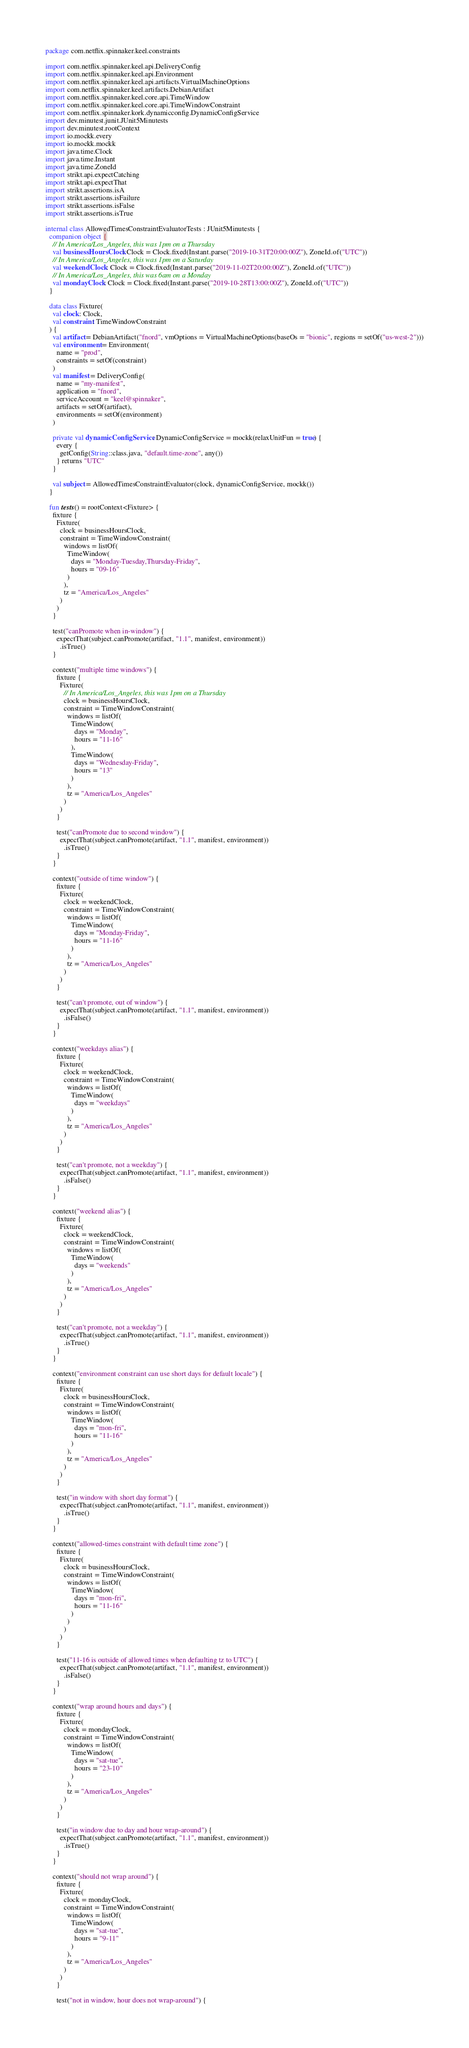<code> <loc_0><loc_0><loc_500><loc_500><_Kotlin_>package com.netflix.spinnaker.keel.constraints

import com.netflix.spinnaker.keel.api.DeliveryConfig
import com.netflix.spinnaker.keel.api.Environment
import com.netflix.spinnaker.keel.api.artifacts.VirtualMachineOptions
import com.netflix.spinnaker.keel.artifacts.DebianArtifact
import com.netflix.spinnaker.keel.core.api.TimeWindow
import com.netflix.spinnaker.keel.core.api.TimeWindowConstraint
import com.netflix.spinnaker.kork.dynamicconfig.DynamicConfigService
import dev.minutest.junit.JUnit5Minutests
import dev.minutest.rootContext
import io.mockk.every
import io.mockk.mockk
import java.time.Clock
import java.time.Instant
import java.time.ZoneId
import strikt.api.expectCatching
import strikt.api.expectThat
import strikt.assertions.isA
import strikt.assertions.isFailure
import strikt.assertions.isFalse
import strikt.assertions.isTrue

internal class AllowedTimesConstraintEvaluatorTests : JUnit5Minutests {
  companion object {
    // In America/Los_Angeles, this was 1pm on a Thursday
    val businessHoursClock: Clock = Clock.fixed(Instant.parse("2019-10-31T20:00:00Z"), ZoneId.of("UTC"))
    // In America/Los_Angeles, this was 1pm on a Saturday
    val weekendClock: Clock = Clock.fixed(Instant.parse("2019-11-02T20:00:00Z"), ZoneId.of("UTC"))
    // In America/Los_Angeles, this was 6am on a Monday
    val mondayClock: Clock = Clock.fixed(Instant.parse("2019-10-28T13:00:00Z"), ZoneId.of("UTC"))
  }

  data class Fixture(
    val clock: Clock,
    val constraint: TimeWindowConstraint
  ) {
    val artifact = DebianArtifact("fnord", vmOptions = VirtualMachineOptions(baseOs = "bionic", regions = setOf("us-west-2")))
    val environment = Environment(
      name = "prod",
      constraints = setOf(constraint)
    )
    val manifest = DeliveryConfig(
      name = "my-manifest",
      application = "fnord",
      serviceAccount = "keel@spinnaker",
      artifacts = setOf(artifact),
      environments = setOf(environment)
    )

    private val dynamicConfigService: DynamicConfigService = mockk(relaxUnitFun = true) {
      every {
        getConfig(String::class.java, "default.time-zone", any())
      } returns "UTC"
    }

    val subject = AllowedTimesConstraintEvaluator(clock, dynamicConfigService, mockk())
  }

  fun tests() = rootContext<Fixture> {
    fixture {
      Fixture(
        clock = businessHoursClock,
        constraint = TimeWindowConstraint(
          windows = listOf(
            TimeWindow(
              days = "Monday-Tuesday,Thursday-Friday",
              hours = "09-16"
            )
          ),
          tz = "America/Los_Angeles"
        )
      )
    }

    test("canPromote when in-window") {
      expectThat(subject.canPromote(artifact, "1.1", manifest, environment))
        .isTrue()
    }

    context("multiple time windows") {
      fixture {
        Fixture(
          // In America/Los_Angeles, this was 1pm on a Thursday
          clock = businessHoursClock,
          constraint = TimeWindowConstraint(
            windows = listOf(
              TimeWindow(
                days = "Monday",
                hours = "11-16"
              ),
              TimeWindow(
                days = "Wednesday-Friday",
                hours = "13"
              )
            ),
            tz = "America/Los_Angeles"
          )
        )
      }

      test("canPromote due to second window") {
        expectThat(subject.canPromote(artifact, "1.1", manifest, environment))
          .isTrue()
      }
    }

    context("outside of time window") {
      fixture {
        Fixture(
          clock = weekendClock,
          constraint = TimeWindowConstraint(
            windows = listOf(
              TimeWindow(
                days = "Monday-Friday",
                hours = "11-16"
              )
            ),
            tz = "America/Los_Angeles"
          )
        )
      }

      test("can't promote, out of window") {
        expectThat(subject.canPromote(artifact, "1.1", manifest, environment))
          .isFalse()
      }
    }

    context("weekdays alias") {
      fixture {
        Fixture(
          clock = weekendClock,
          constraint = TimeWindowConstraint(
            windows = listOf(
              TimeWindow(
                days = "weekdays"
              )
            ),
            tz = "America/Los_Angeles"
          )
        )
      }

      test("can't promote, not a weekday") {
        expectThat(subject.canPromote(artifact, "1.1", manifest, environment))
          .isFalse()
      }
    }

    context("weekend alias") {
      fixture {
        Fixture(
          clock = weekendClock,
          constraint = TimeWindowConstraint(
            windows = listOf(
              TimeWindow(
                days = "weekends"
              )
            ),
            tz = "America/Los_Angeles"
          )
        )
      }

      test("can't promote, not a weekday") {
        expectThat(subject.canPromote(artifact, "1.1", manifest, environment))
          .isTrue()
      }
    }

    context("environment constraint can use short days for default locale") {
      fixture {
        Fixture(
          clock = businessHoursClock,
          constraint = TimeWindowConstraint(
            windows = listOf(
              TimeWindow(
                days = "mon-fri",
                hours = "11-16"
              )
            ),
            tz = "America/Los_Angeles"
          )
        )
      }

      test("in window with short day format") {
        expectThat(subject.canPromote(artifact, "1.1", manifest, environment))
          .isTrue()
      }
    }

    context("allowed-times constraint with default time zone") {
      fixture {
        Fixture(
          clock = businessHoursClock,
          constraint = TimeWindowConstraint(
            windows = listOf(
              TimeWindow(
                days = "mon-fri",
                hours = "11-16"
              )
            )
          )
        )
      }

      test("11-16 is outside of allowed times when defaulting tz to UTC") {
        expectThat(subject.canPromote(artifact, "1.1", manifest, environment))
          .isFalse()
      }
    }

    context("wrap around hours and days") {
      fixture {
        Fixture(
          clock = mondayClock,
          constraint = TimeWindowConstraint(
            windows = listOf(
              TimeWindow(
                days = "sat-tue",
                hours = "23-10"
              )
            ),
            tz = "America/Los_Angeles"
          )
        )
      }

      test("in window due to day and hour wrap-around") {
        expectThat(subject.canPromote(artifact, "1.1", manifest, environment))
          .isTrue()
      }
    }

    context("should not wrap around") {
      fixture {
        Fixture(
          clock = mondayClock,
          constraint = TimeWindowConstraint(
            windows = listOf(
              TimeWindow(
                days = "sat-tue",
                hours = "9-11"
              )
            ),
            tz = "America/Los_Angeles"
          )
        )
      }

      test("not in window, hour does not wrap-around") {</code> 